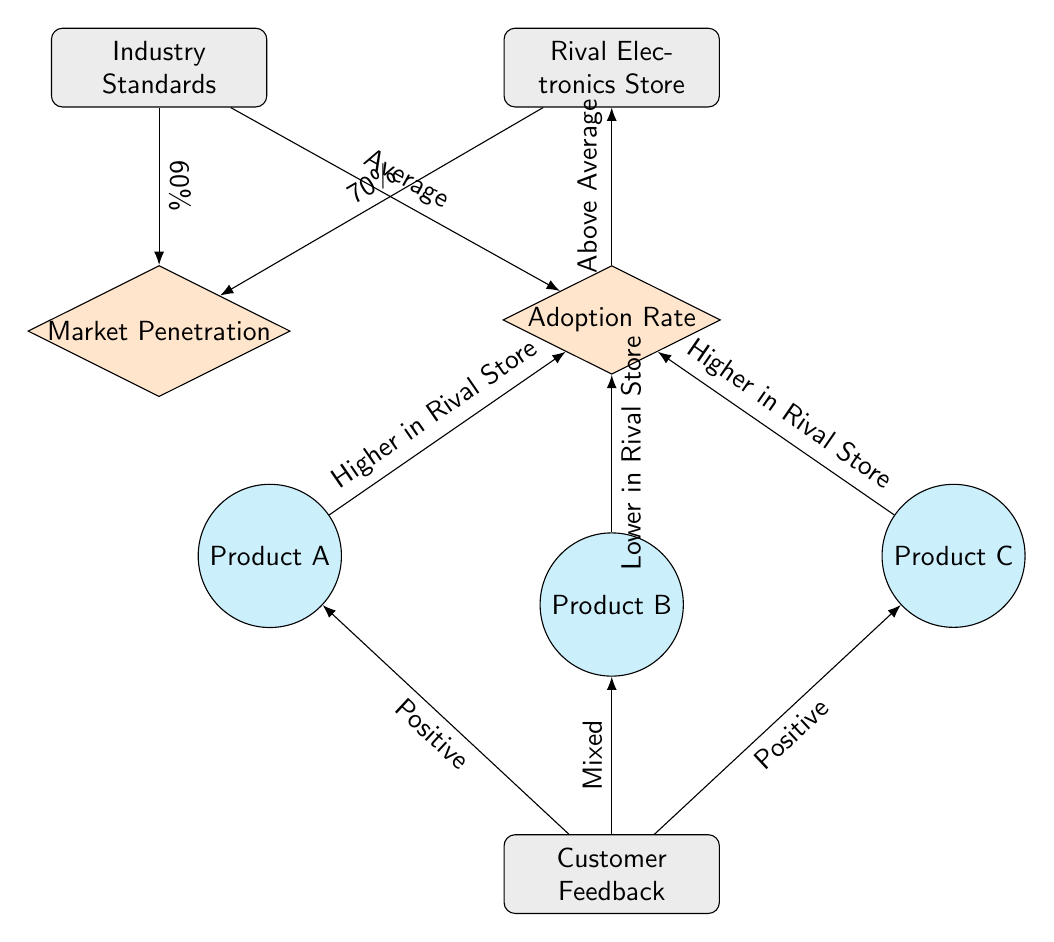What is the market penetration percentage according to industry standards? The diagram shows a direct edge from Industry Standards to Market Penetration, labeled with "60%". Therefore, the market penetration percentage according to industry standards is indicated by this label.
Answer: 60% What is the adoption rate percentage for the Rival Electronics Store? Looking at the edge connecting Rival Electronics Store and Adoption Rate, it is labeled "Above Average". While a numerical percentage isn't given, this indicates that the adoption rate is above the average percentage, which is likely inferred from the context.
Answer: Above Average Which product has a higher adoption rate in the Rival Electronics Store, Product A or Product B? The edges from Product A and Product B to Adoption Rate state "Higher in Rival Store" for Product A and "Lower in Rival Store" for Product B. Therefore, by comparing these labels, it’s clear that Product A has a higher adoption rate in the Rival Electronics Store than Product B.
Answer: Product A What kind of customer feedback does Product C receive? The edge from Customer Feedback to Product C is labeled "Positive", which indicates the type of feedback being received for this product.
Answer: Positive How do adoption rates in the Rival Electronics Store compare to industry standards? The diagram shows that the Rival Electronics Store's adoption rate is marked as "Above Average" when connected to the Industry Standards node. This suggests a comparison in which Rival Electronics Store exceeds the average adoption rate when compared to the industry standard.
Answer: Above Average What type of feedback does Product B receive from customers? The edge leading from Customer Feedback to Product B is labeled "Mixed". This indicates that the customer feedback for Product B is not entirely positive or negative but rather a blend of different opinions.
Answer: Mixed What is the relationship between Market Penetration and Industry Standards? The diagram clearly shows an edge between Industry Standards and Market Penetration indicating a direct relationship, with Market Penetration representing a portion of the standards defined by the industry.
Answer: Direct relationship How many products are shown in the adoption rate section? There are three distinct products connected to the Adoption Rate node: Product A, Product B, and Product C. By counting the nodes, the total number of products can be determined.
Answer: Three 